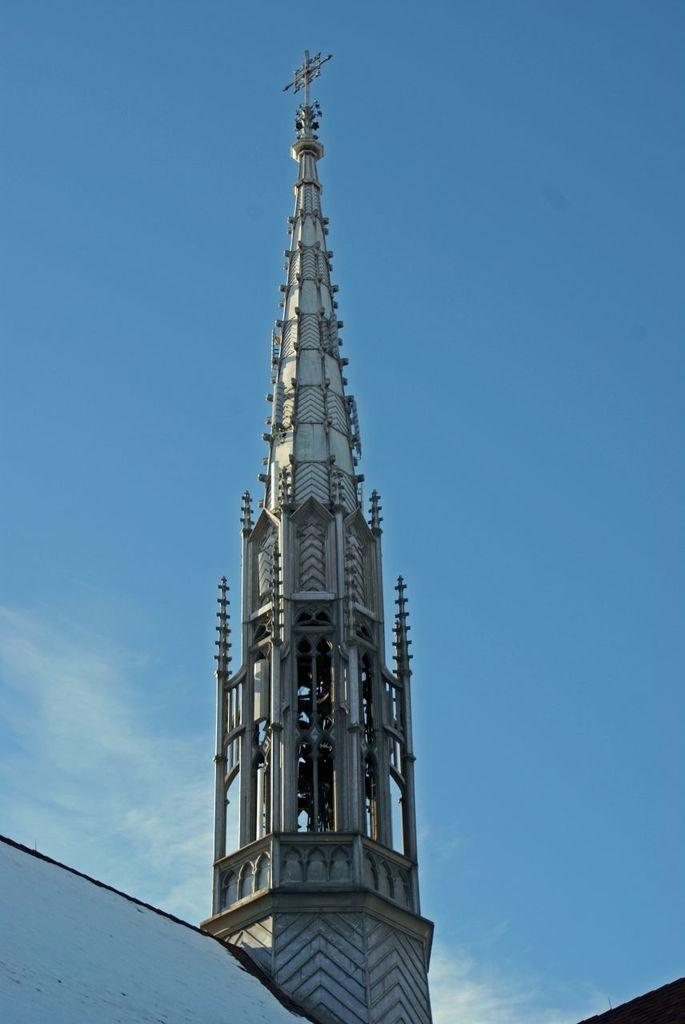What is the main structure in the picture? There is a tower in the picture. What can be seen in the background of the picture? The sky is visible in the background of the picture. What type of jewel is hanging from the tower in the image? There is no jewel hanging from the tower in the image; it only features the tower and the sky in the background. 